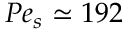Convert formula to latex. <formula><loc_0><loc_0><loc_500><loc_500>P e _ { s } \simeq 1 9 2</formula> 